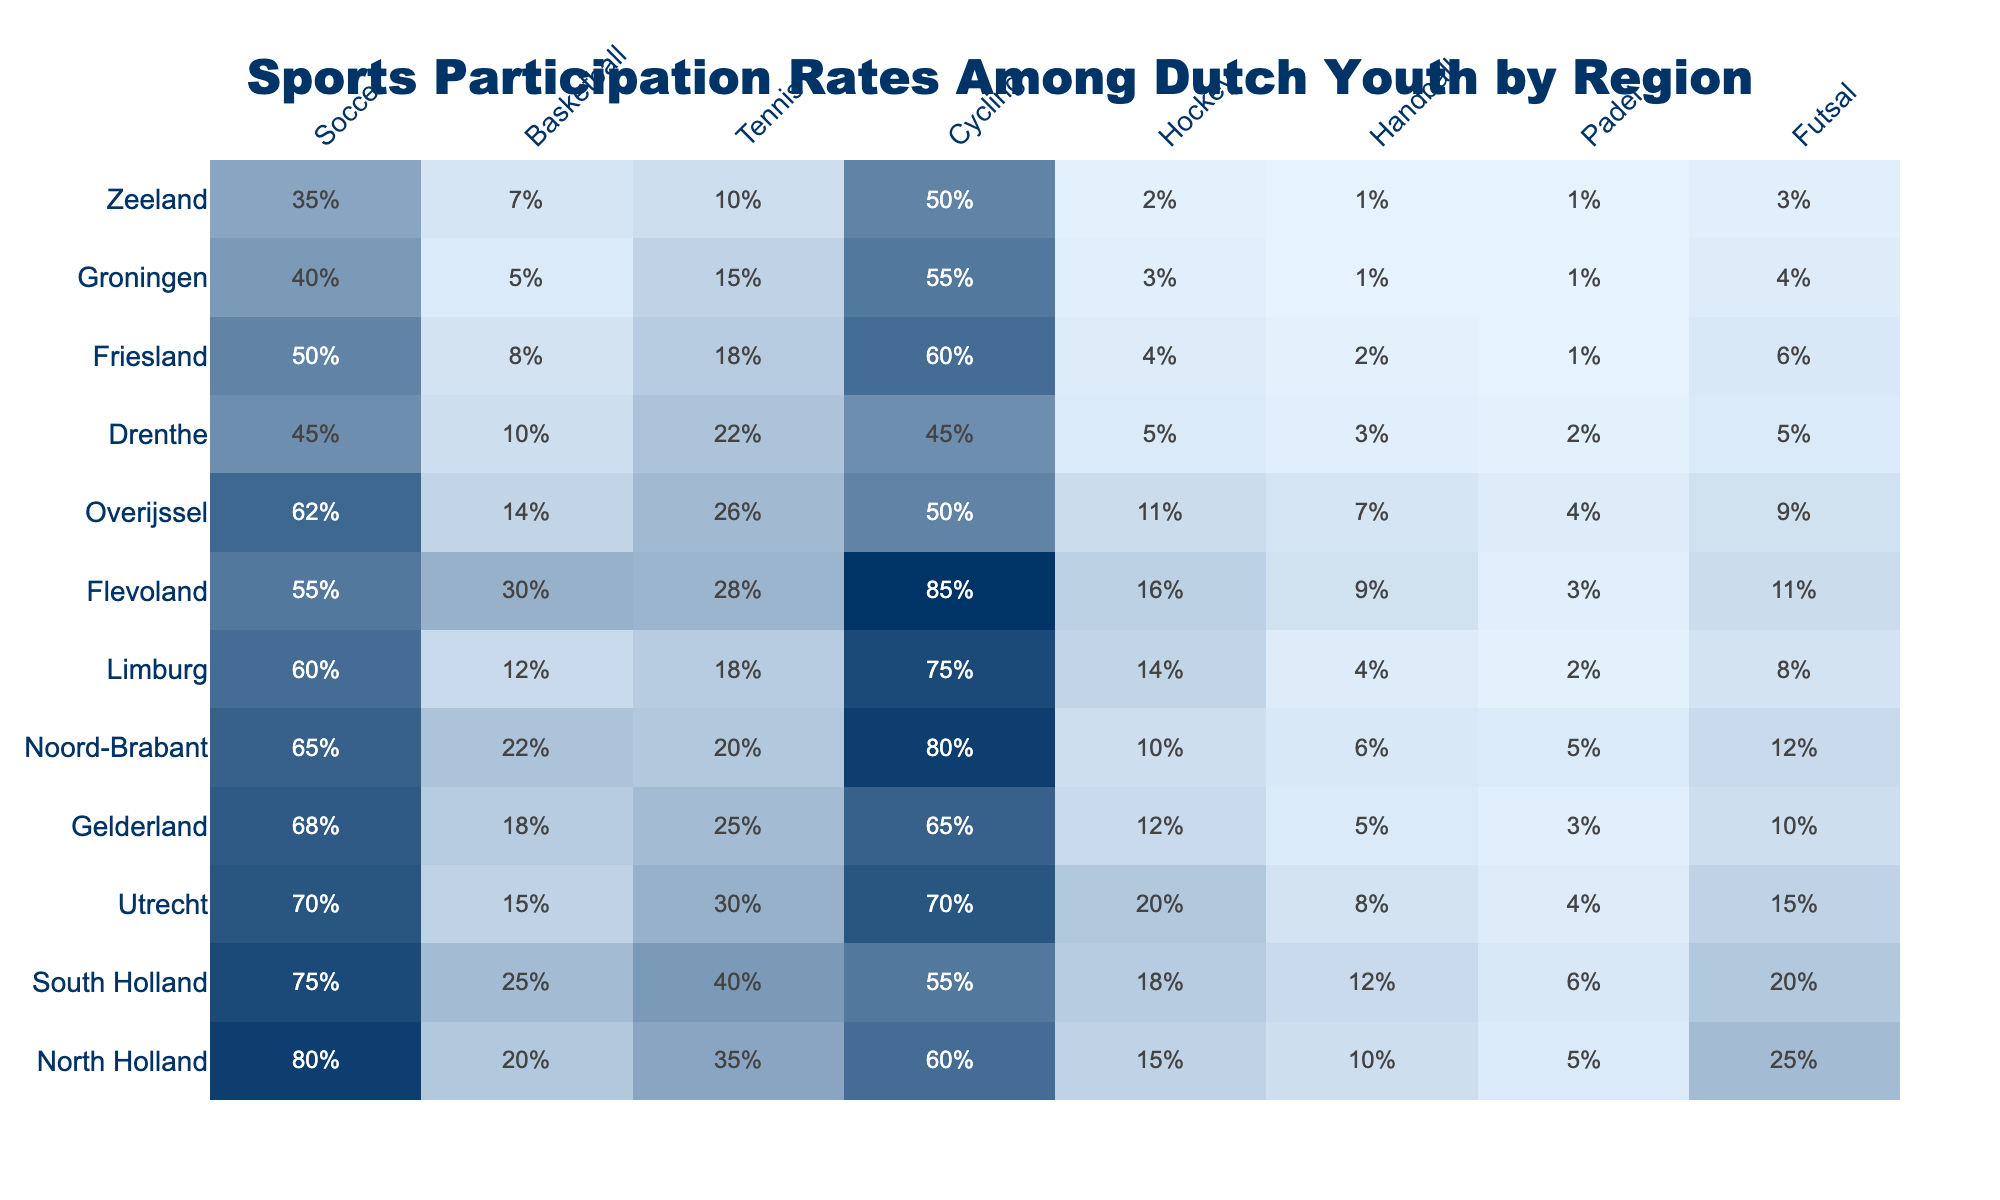What region has the highest soccer participation rate? By examining the table, North Holland has the highest soccer participation rate at 80%.
Answer: North Holland What is the participation rate for handball in Limburg? The table shows that the participation rate for handball in Limburg is 4%.
Answer: 4% Which sport has the lowest participation rate in Friesland? In Friesland, the sport with the lowest participation rate is futsal, with only 1%.
Answer: Futsal What is the average participation rate for cycling across all regions? To find the average, sum the cycling participation rates: 60 + 55 + 70 + 65 + 80 + 75 + 85 + 50 + 45 + 60 + 55 + 50 = 790. There are 12 regions, so the average is 790/12 ≈ 65.83.
Answer: Approximately 65.83 Is handball more popular than futsal in South Holland? In South Holland, handball has a participation rate of 12%, while futsal has a rate of 6%. Therefore, handball is more popular than futsal.
Answer: Yes Which region has the closest soccer and basketball participation rates? Looking at the table, both Noord-Brabant and South Holland have participation rates for soccer and basketball that are relatively close: 65% and 22% for Noord-Brabant, and 75% and 25% for South Holland. The difference in rates is similar, but we can see that South Holland has the closest values at 75% and 25%.
Answer: South Holland What is the difference in tennis participation rates between North Holland and Drenthe? The participation rate in North Holland for tennis is 35%, while in Drenthe it is 22%. The difference is calculated as 35% - 22% = 13%.
Answer: 13% How many regions have a cycling participation rate above 70%? From the table, the regions with cycling participation rates above 70% are Noord-Brabant (80%), Flevoland (85%), and Utrecht (70%). Therefore, there are 3 regions.
Answer: 3 Which sport has the lowest average participation across all regions? First, calculate the average participation for each sport, then compare: Soccer: (80 + 75 + 70 + 68 + 65 + 60 + 55 + 62 + 45 + 50 + 40 + 35) / 12 = 62.5, Basketball: (20 + 25 + 15 + 18 + 22 + 12 + 30 + 14 + 10 + 8 + 5 + 7) / 12 ≈ 15, Tennis: (35 + 40 + 30 + 25 + 20 + 18 + 28 + 26 + 22 + 18 + 15 + 10) / 12 = 23.5, Cycling: (60 + 55 + 70 + 65 + 80 + 75 + 85 + 50 + 45 + 60 + 55 + 50) / 12 = 65.83, Hockey (average calculated as 12), Handball has (average calculated as 6), Padel (average 4). Comparing these gives the lowest average to basketball.
Answer: Basketball Which region plays more padel than hockey? In the table, the only region where the padel participation rate (5 in Noord-Brabant) exceeds the hockey participation rate (10 in North Holland) is South Holland, where padel is at 6% and hockey is at 18%, also Friesland is at 2% on both sides.
Answer: South Holland 